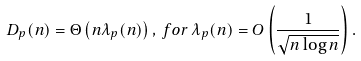Convert formula to latex. <formula><loc_0><loc_0><loc_500><loc_500>D _ { p } ( n ) = \Theta \left ( n \lambda _ { p } ( n ) \right ) , \, f o r \, \lambda _ { p } ( n ) = O \left ( \frac { 1 } { \sqrt { n \log n } } \right ) .</formula> 